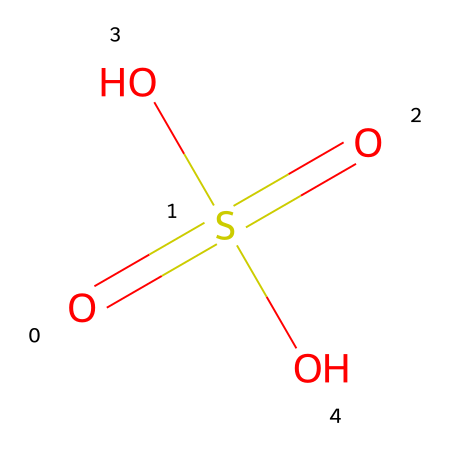What is the name of this chemical? The SMILES representation corresponds to a well-known acid that is characterized by a sulfur atom surrounded by four oxygen atoms, two of which are doubly bonded to the sulfur, which is typical for sulfuric acid.
Answer: sulfuric acid How many oxygen atoms are present in this molecule? By analyzing the SMILES notation, we can identify that there are four oxygen atoms in total, indicated by the four 'O's in the structure.
Answer: four What is the oxidation state of sulfur in this chemical? From the structure given in the SMILES, we can determine that sulfur, being bonded to four oxygen atoms (two with double bonds), has an oxidation state of +6. Each double bond contributes +4, and with the remaining bonds adjusted, it consistently adds to +6.
Answer: +6 Is this acid strong or weak? Sulfuric acid, represented by this chemical structure, is classified as a strong acid because it fully dissociates in water, releasing all its H+ ions.
Answer: strong How many hydrogen atoms does this acid contain? In the structure provided, there are two -OH groups indicating that there are two hydrogen atoms associated with the sulfuric acid molecule.
Answer: two What is the primary use of sulfuric acid in car batteries? In car batteries, sulfuric acid acts as the electrolyte, facilitating the flow of electric current by allowing the transport of ions between the cathode and anode.
Answer: electrolyte 